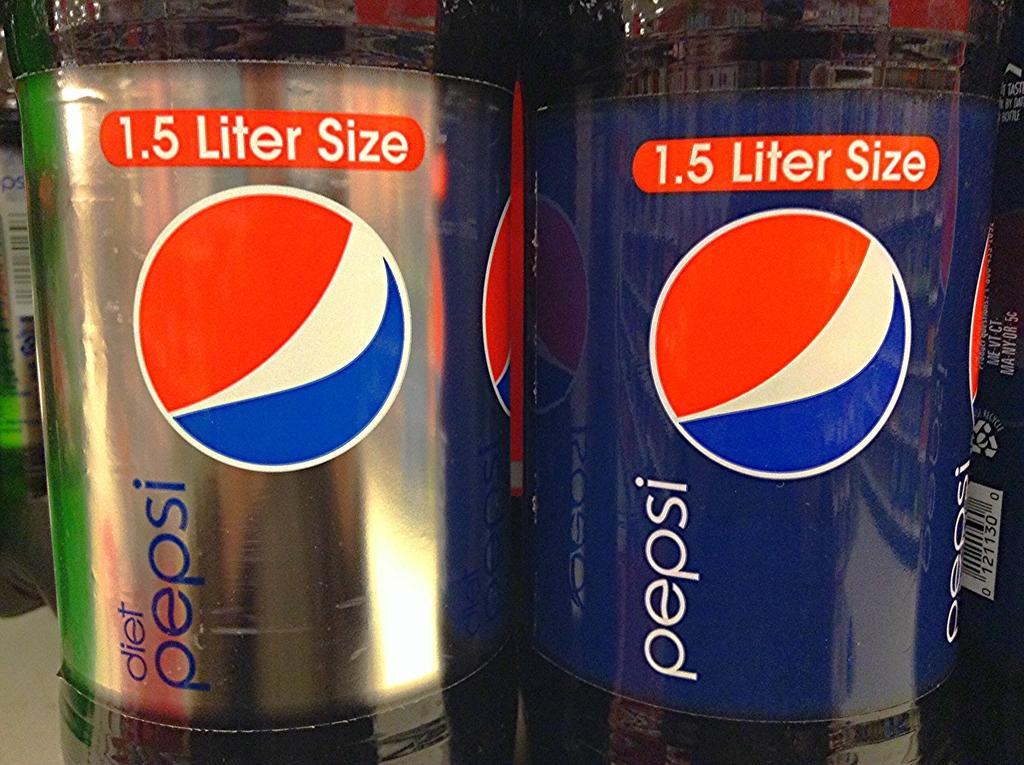<image>
Summarize the visual content of the image. a bottle of diet pepsi standing next to a bottl of regular pepsi 